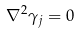<formula> <loc_0><loc_0><loc_500><loc_500>\nabla ^ { 2 } \gamma _ { j } = 0</formula> 